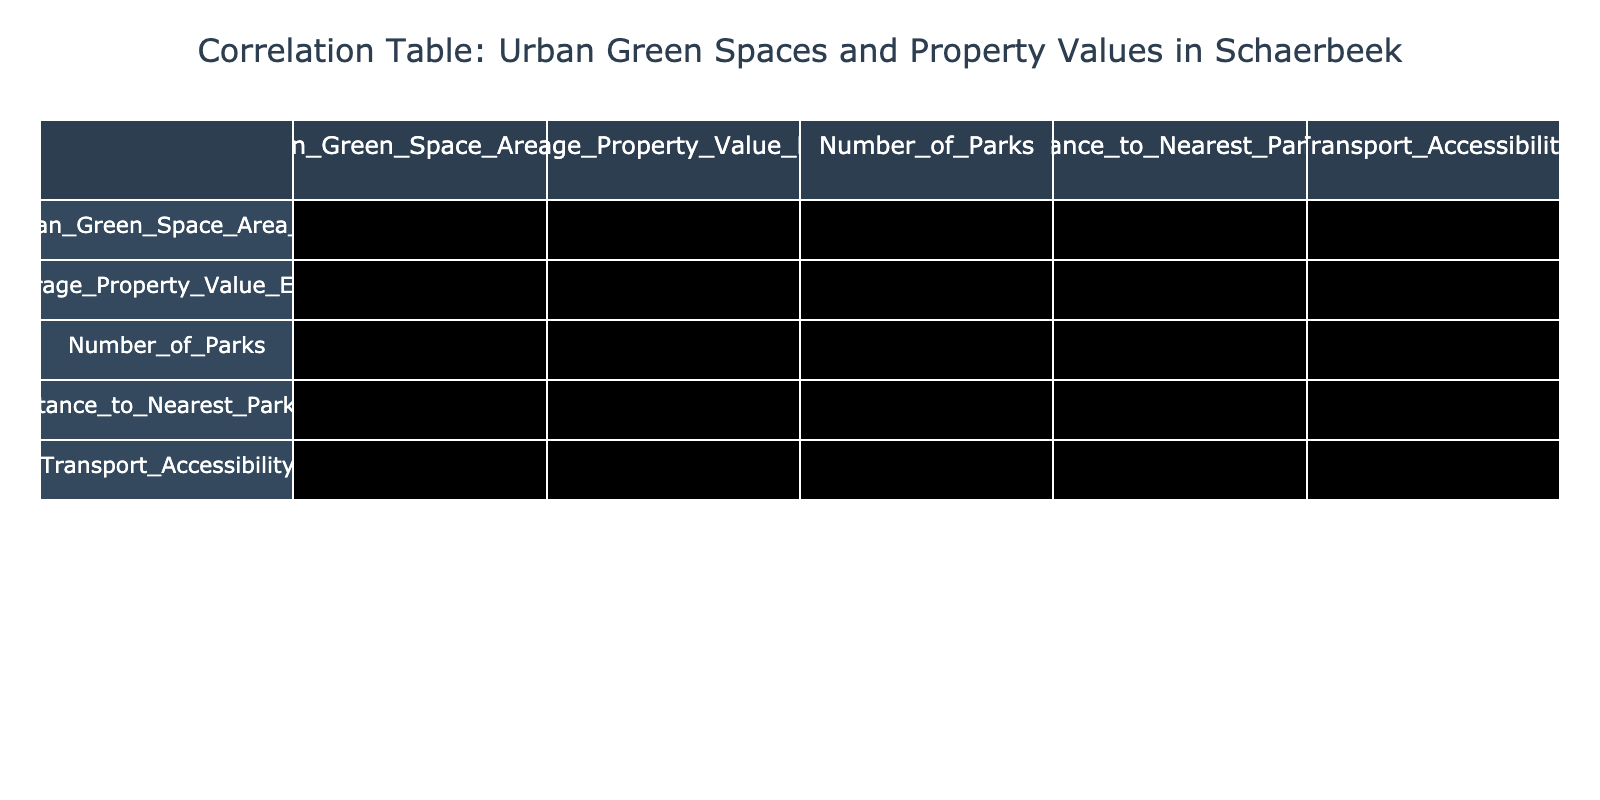What is the average property value for the urban green spaces with an area of 1000 m2? From the table, the average property value for the data point with 1000 m2 is 400,000 euros.
Answer: 400000 Is there a park within 300 meters for the property valued at 220,000 euros? Yes, the property valued at 220,000 euros is at 300 meters distance from the nearest park, which means it meets the condition.
Answer: Yes What is the total number of parks in Schaerbeek represented in the data? By adding the number of parks: 3 + 5 + 4 + 6 + 7 + 2 + 5 + 1 = 33 parks.
Answer: 33 Which urban green space area has the highest property value, and what is that value? The area with the highest property value is 2000 m2, and its value is 470,000 euros.
Answer: 470000 Does increasing the urban green space area correlate with increased average property values? Based on the correlation table, the relationship shows a positive correlation which indicates that as the urban green space area increases, property values tend to increase as well.
Answer: Yes What is the average distance to the nearest park for properties valued above 300,000 euros? The properties valued above 300,000 euros are at distances of 200 m, 150 m, 100 m, and 50 m. Their average distance is (200 + 150 + 100 + 50) / 4 = 125 m.
Answer: 125 How many properties are located within 400 meters of a park? The properties within 400 meters from a park are those with distances of 300 m, 200 m, 150 m, 100 m, and 50 m. This totals to 5 properties.
Answer: 5 Is the property value for urban green spaces at 600 m2 higher than the average property value of the whole dataset? The average property value from all data points is (220,000 + 350,000 + 280,000 + 400,000 + 470,000 + 250,000 + 360,000 + 210,000) / 8 = 319,375. The 600 m2 property value is 250,000, which is lower than the average.
Answer: No What is the sum of the public transport accessibility scores for all urban green spaces? The public transport accessibility scores are 8, 9, 7, 10, 10, 6, 8, and 5. The sum is 8 + 9 + 7 + 10 + 10 + 6 + 8 + 5 = 63.
Answer: 63 